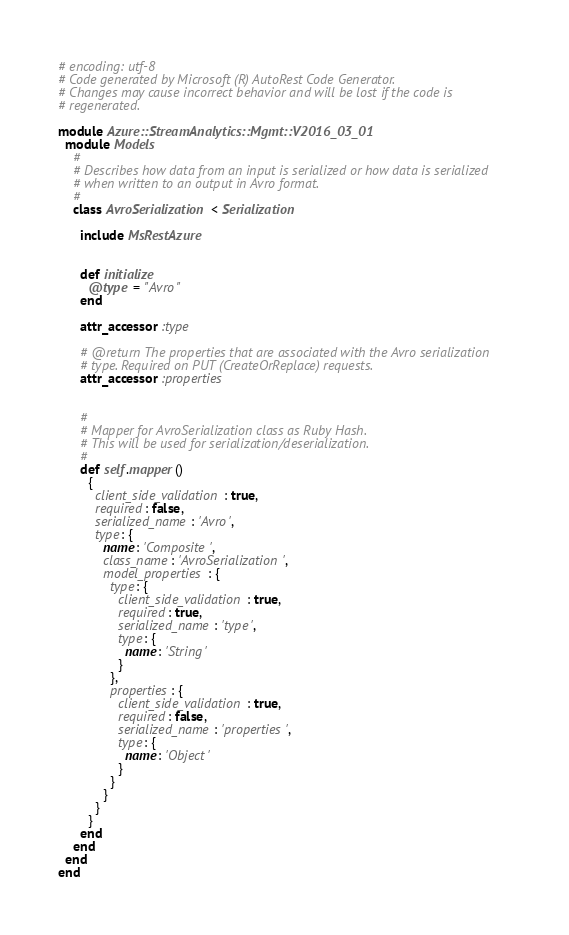<code> <loc_0><loc_0><loc_500><loc_500><_Ruby_># encoding: utf-8
# Code generated by Microsoft (R) AutoRest Code Generator.
# Changes may cause incorrect behavior and will be lost if the code is
# regenerated.

module Azure::StreamAnalytics::Mgmt::V2016_03_01
  module Models
    #
    # Describes how data from an input is serialized or how data is serialized
    # when written to an output in Avro format.
    #
    class AvroSerialization < Serialization

      include MsRestAzure


      def initialize
        @type = "Avro"
      end

      attr_accessor :type

      # @return The properties that are associated with the Avro serialization
      # type. Required on PUT (CreateOrReplace) requests.
      attr_accessor :properties


      #
      # Mapper for AvroSerialization class as Ruby Hash.
      # This will be used for serialization/deserialization.
      #
      def self.mapper()
        {
          client_side_validation: true,
          required: false,
          serialized_name: 'Avro',
          type: {
            name: 'Composite',
            class_name: 'AvroSerialization',
            model_properties: {
              type: {
                client_side_validation: true,
                required: true,
                serialized_name: 'type',
                type: {
                  name: 'String'
                }
              },
              properties: {
                client_side_validation: true,
                required: false,
                serialized_name: 'properties',
                type: {
                  name: 'Object'
                }
              }
            }
          }
        }
      end
    end
  end
end
</code> 